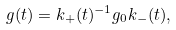<formula> <loc_0><loc_0><loc_500><loc_500>g ( t ) = k _ { + } ( t ) ^ { - 1 } g _ { 0 } k _ { - } ( t ) ,</formula> 